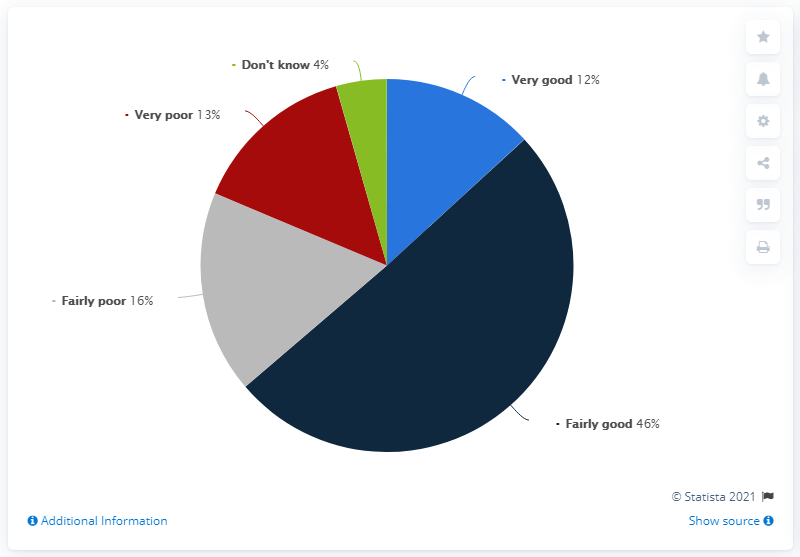Give some essential details in this illustration. The difference between "fairly good" and "fairly poor" is that "fairly good" refers to a level of quality or performance that is satisfactory or acceptable, while "fairly poor" implies a level of quality or performance that is subpar or unsatisfactory. In the pie chart, dark blue represents fairly good. 